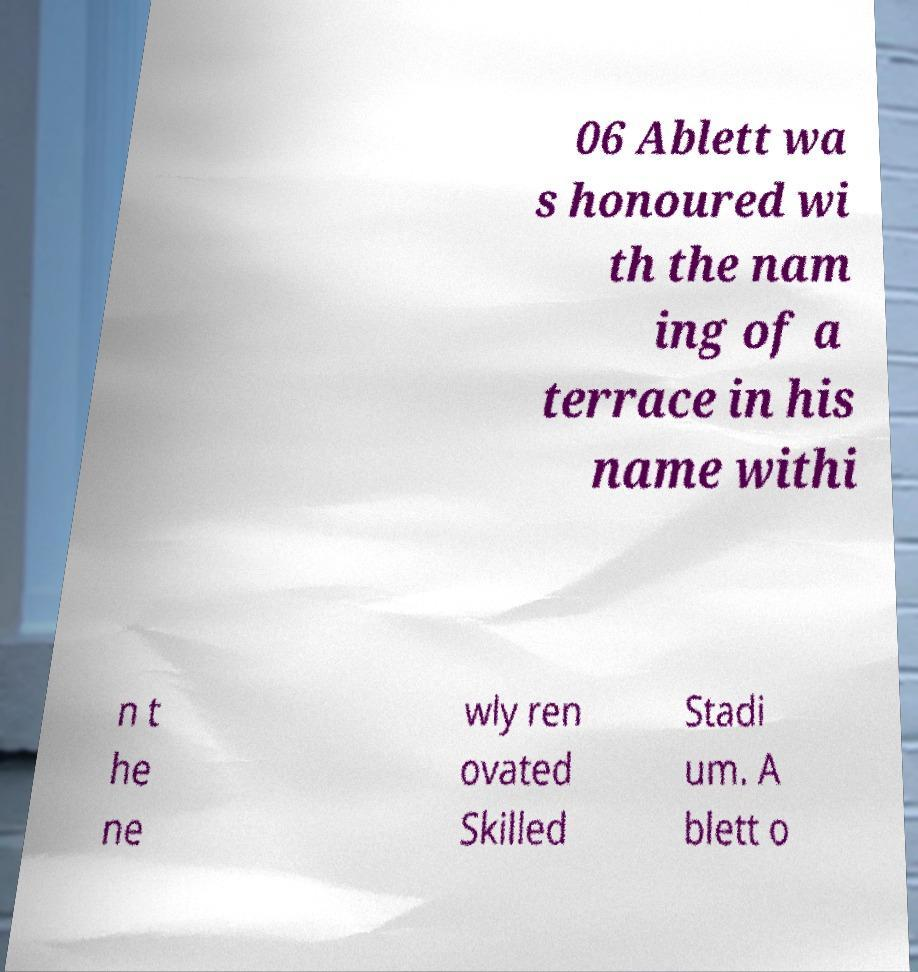Can you read and provide the text displayed in the image?This photo seems to have some interesting text. Can you extract and type it out for me? 06 Ablett wa s honoured wi th the nam ing of a terrace in his name withi n t he ne wly ren ovated Skilled Stadi um. A blett o 